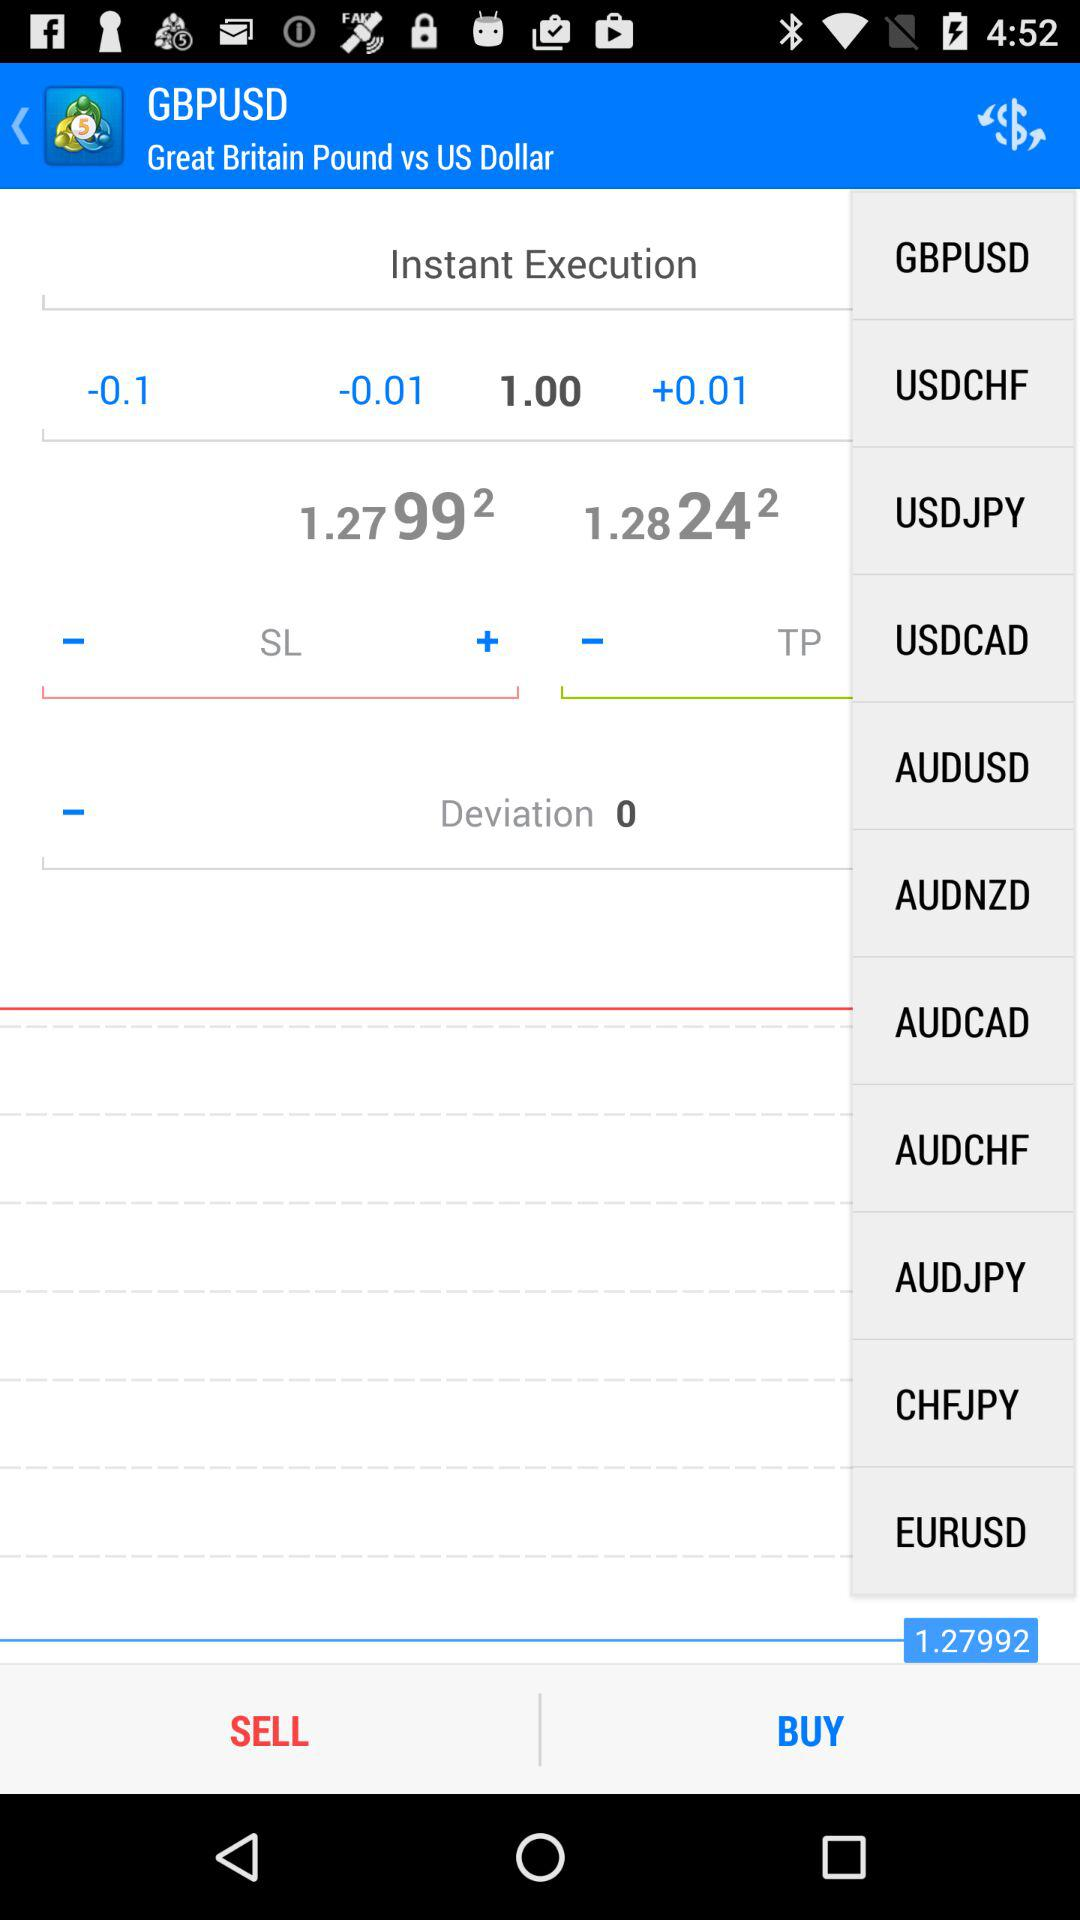What is the name of the application?
When the provided information is insufficient, respond with <no answer>. <no answer> 